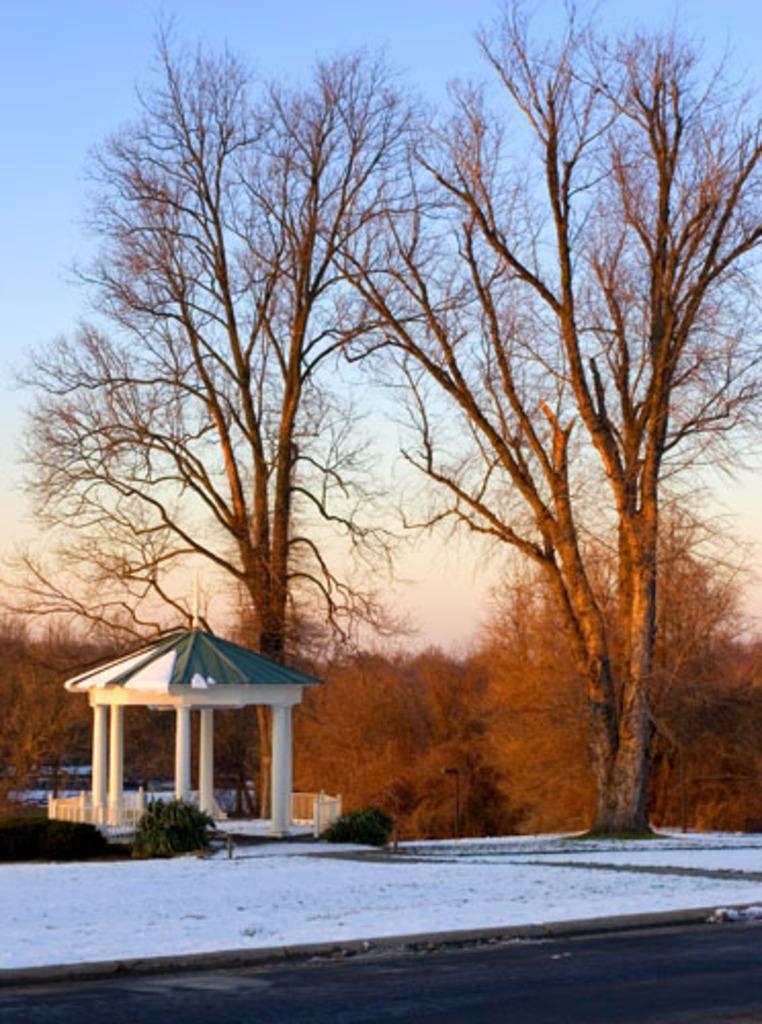What type of vegetation is present on the ground in the image? There are trees and plants on the ground in the image. What is the weather like in the image? There is snow visible in the image, indicating a cold and likely wintery scene. How would you describe the sky in the image? The sky is blue and cloudy in the image. What type of furniture can be seen in the image? There is no furniture present in the image; it features trees, plants, snow, and a blue, cloudy sky. How does the noise level in the image compare to a busy city street? The image does not provide any information about noise levels, as it focuses on the visual aspects of the scene. 